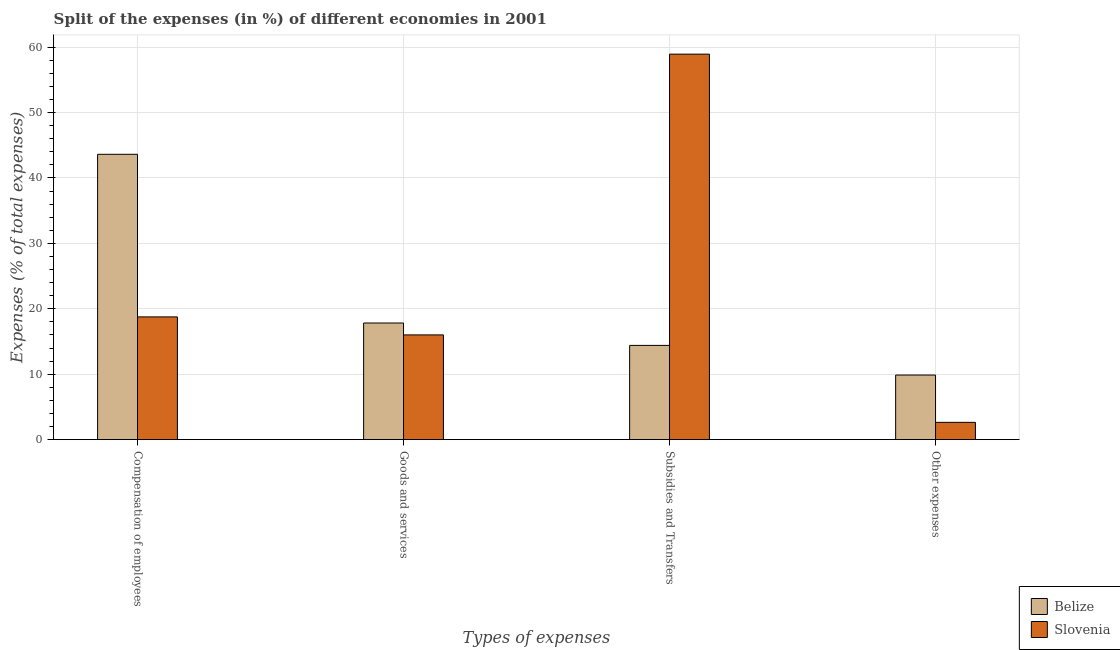How many different coloured bars are there?
Your response must be concise. 2. How many groups of bars are there?
Make the answer very short. 4. Are the number of bars per tick equal to the number of legend labels?
Keep it short and to the point. Yes. Are the number of bars on each tick of the X-axis equal?
Provide a succinct answer. Yes. How many bars are there on the 3rd tick from the left?
Make the answer very short. 2. What is the label of the 2nd group of bars from the left?
Give a very brief answer. Goods and services. What is the percentage of amount spent on compensation of employees in Belize?
Keep it short and to the point. 43.61. Across all countries, what is the maximum percentage of amount spent on other expenses?
Provide a short and direct response. 9.87. Across all countries, what is the minimum percentage of amount spent on compensation of employees?
Give a very brief answer. 18.76. In which country was the percentage of amount spent on goods and services maximum?
Provide a short and direct response. Belize. In which country was the percentage of amount spent on other expenses minimum?
Keep it short and to the point. Slovenia. What is the total percentage of amount spent on other expenses in the graph?
Give a very brief answer. 12.51. What is the difference between the percentage of amount spent on compensation of employees in Belize and that in Slovenia?
Give a very brief answer. 24.85. What is the difference between the percentage of amount spent on compensation of employees in Belize and the percentage of amount spent on other expenses in Slovenia?
Provide a short and direct response. 40.97. What is the average percentage of amount spent on goods and services per country?
Offer a very short reply. 16.91. What is the difference between the percentage of amount spent on subsidies and percentage of amount spent on goods and services in Slovenia?
Your answer should be compact. 42.91. In how many countries, is the percentage of amount spent on goods and services greater than 58 %?
Provide a succinct answer. 0. What is the ratio of the percentage of amount spent on subsidies in Belize to that in Slovenia?
Keep it short and to the point. 0.24. What is the difference between the highest and the second highest percentage of amount spent on compensation of employees?
Give a very brief answer. 24.85. What is the difference between the highest and the lowest percentage of amount spent on goods and services?
Your answer should be compact. 1.82. In how many countries, is the percentage of amount spent on goods and services greater than the average percentage of amount spent on goods and services taken over all countries?
Your response must be concise. 1. What does the 1st bar from the left in Compensation of employees represents?
Offer a terse response. Belize. What does the 2nd bar from the right in Compensation of employees represents?
Provide a short and direct response. Belize. Is it the case that in every country, the sum of the percentage of amount spent on compensation of employees and percentage of amount spent on goods and services is greater than the percentage of amount spent on subsidies?
Give a very brief answer. No. How many bars are there?
Give a very brief answer. 8. What is the difference between two consecutive major ticks on the Y-axis?
Provide a short and direct response. 10. Does the graph contain any zero values?
Provide a short and direct response. No. Does the graph contain grids?
Provide a succinct answer. Yes. How many legend labels are there?
Ensure brevity in your answer.  2. How are the legend labels stacked?
Your answer should be very brief. Vertical. What is the title of the graph?
Provide a succinct answer. Split of the expenses (in %) of different economies in 2001. What is the label or title of the X-axis?
Provide a short and direct response. Types of expenses. What is the label or title of the Y-axis?
Ensure brevity in your answer.  Expenses (% of total expenses). What is the Expenses (% of total expenses) of Belize in Compensation of employees?
Your answer should be very brief. 43.61. What is the Expenses (% of total expenses) of Slovenia in Compensation of employees?
Ensure brevity in your answer.  18.76. What is the Expenses (% of total expenses) in Belize in Goods and services?
Ensure brevity in your answer.  17.82. What is the Expenses (% of total expenses) of Slovenia in Goods and services?
Your answer should be compact. 16.01. What is the Expenses (% of total expenses) in Belize in Subsidies and Transfers?
Give a very brief answer. 14.4. What is the Expenses (% of total expenses) in Slovenia in Subsidies and Transfers?
Your response must be concise. 58.92. What is the Expenses (% of total expenses) in Belize in Other expenses?
Offer a very short reply. 9.87. What is the Expenses (% of total expenses) in Slovenia in Other expenses?
Give a very brief answer. 2.64. Across all Types of expenses, what is the maximum Expenses (% of total expenses) of Belize?
Make the answer very short. 43.61. Across all Types of expenses, what is the maximum Expenses (% of total expenses) in Slovenia?
Your response must be concise. 58.92. Across all Types of expenses, what is the minimum Expenses (% of total expenses) of Belize?
Make the answer very short. 9.87. Across all Types of expenses, what is the minimum Expenses (% of total expenses) in Slovenia?
Keep it short and to the point. 2.64. What is the total Expenses (% of total expenses) of Belize in the graph?
Offer a very short reply. 85.7. What is the total Expenses (% of total expenses) of Slovenia in the graph?
Provide a succinct answer. 96.32. What is the difference between the Expenses (% of total expenses) of Belize in Compensation of employees and that in Goods and services?
Ensure brevity in your answer.  25.79. What is the difference between the Expenses (% of total expenses) of Slovenia in Compensation of employees and that in Goods and services?
Provide a succinct answer. 2.75. What is the difference between the Expenses (% of total expenses) in Belize in Compensation of employees and that in Subsidies and Transfers?
Provide a succinct answer. 29.21. What is the difference between the Expenses (% of total expenses) of Slovenia in Compensation of employees and that in Subsidies and Transfers?
Ensure brevity in your answer.  -40.16. What is the difference between the Expenses (% of total expenses) of Belize in Compensation of employees and that in Other expenses?
Your answer should be compact. 33.74. What is the difference between the Expenses (% of total expenses) in Slovenia in Compensation of employees and that in Other expenses?
Ensure brevity in your answer.  16.12. What is the difference between the Expenses (% of total expenses) in Belize in Goods and services and that in Subsidies and Transfers?
Your answer should be compact. 3.42. What is the difference between the Expenses (% of total expenses) of Slovenia in Goods and services and that in Subsidies and Transfers?
Keep it short and to the point. -42.91. What is the difference between the Expenses (% of total expenses) in Belize in Goods and services and that in Other expenses?
Keep it short and to the point. 7.95. What is the difference between the Expenses (% of total expenses) in Slovenia in Goods and services and that in Other expenses?
Offer a very short reply. 13.37. What is the difference between the Expenses (% of total expenses) of Belize in Subsidies and Transfers and that in Other expenses?
Ensure brevity in your answer.  4.53. What is the difference between the Expenses (% of total expenses) of Slovenia in Subsidies and Transfers and that in Other expenses?
Provide a short and direct response. 56.28. What is the difference between the Expenses (% of total expenses) in Belize in Compensation of employees and the Expenses (% of total expenses) in Slovenia in Goods and services?
Your answer should be very brief. 27.6. What is the difference between the Expenses (% of total expenses) in Belize in Compensation of employees and the Expenses (% of total expenses) in Slovenia in Subsidies and Transfers?
Your response must be concise. -15.31. What is the difference between the Expenses (% of total expenses) of Belize in Compensation of employees and the Expenses (% of total expenses) of Slovenia in Other expenses?
Offer a very short reply. 40.97. What is the difference between the Expenses (% of total expenses) of Belize in Goods and services and the Expenses (% of total expenses) of Slovenia in Subsidies and Transfers?
Offer a terse response. -41.1. What is the difference between the Expenses (% of total expenses) of Belize in Goods and services and the Expenses (% of total expenses) of Slovenia in Other expenses?
Give a very brief answer. 15.18. What is the difference between the Expenses (% of total expenses) of Belize in Subsidies and Transfers and the Expenses (% of total expenses) of Slovenia in Other expenses?
Make the answer very short. 11.76. What is the average Expenses (% of total expenses) of Belize per Types of expenses?
Your answer should be compact. 21.43. What is the average Expenses (% of total expenses) of Slovenia per Types of expenses?
Your answer should be compact. 24.08. What is the difference between the Expenses (% of total expenses) in Belize and Expenses (% of total expenses) in Slovenia in Compensation of employees?
Your answer should be compact. 24.85. What is the difference between the Expenses (% of total expenses) of Belize and Expenses (% of total expenses) of Slovenia in Goods and services?
Make the answer very short. 1.82. What is the difference between the Expenses (% of total expenses) of Belize and Expenses (% of total expenses) of Slovenia in Subsidies and Transfers?
Ensure brevity in your answer.  -44.52. What is the difference between the Expenses (% of total expenses) of Belize and Expenses (% of total expenses) of Slovenia in Other expenses?
Keep it short and to the point. 7.23. What is the ratio of the Expenses (% of total expenses) of Belize in Compensation of employees to that in Goods and services?
Provide a short and direct response. 2.45. What is the ratio of the Expenses (% of total expenses) of Slovenia in Compensation of employees to that in Goods and services?
Your answer should be very brief. 1.17. What is the ratio of the Expenses (% of total expenses) in Belize in Compensation of employees to that in Subsidies and Transfers?
Offer a very short reply. 3.03. What is the ratio of the Expenses (% of total expenses) of Slovenia in Compensation of employees to that in Subsidies and Transfers?
Offer a very short reply. 0.32. What is the ratio of the Expenses (% of total expenses) in Belize in Compensation of employees to that in Other expenses?
Offer a very short reply. 4.42. What is the ratio of the Expenses (% of total expenses) of Slovenia in Compensation of employees to that in Other expenses?
Your answer should be compact. 7.11. What is the ratio of the Expenses (% of total expenses) of Belize in Goods and services to that in Subsidies and Transfers?
Ensure brevity in your answer.  1.24. What is the ratio of the Expenses (% of total expenses) of Slovenia in Goods and services to that in Subsidies and Transfers?
Offer a very short reply. 0.27. What is the ratio of the Expenses (% of total expenses) of Belize in Goods and services to that in Other expenses?
Keep it short and to the point. 1.81. What is the ratio of the Expenses (% of total expenses) in Slovenia in Goods and services to that in Other expenses?
Your answer should be compact. 6.07. What is the ratio of the Expenses (% of total expenses) of Belize in Subsidies and Transfers to that in Other expenses?
Your answer should be compact. 1.46. What is the ratio of the Expenses (% of total expenses) of Slovenia in Subsidies and Transfers to that in Other expenses?
Offer a very short reply. 22.33. What is the difference between the highest and the second highest Expenses (% of total expenses) of Belize?
Your answer should be compact. 25.79. What is the difference between the highest and the second highest Expenses (% of total expenses) of Slovenia?
Make the answer very short. 40.16. What is the difference between the highest and the lowest Expenses (% of total expenses) of Belize?
Make the answer very short. 33.74. What is the difference between the highest and the lowest Expenses (% of total expenses) in Slovenia?
Offer a terse response. 56.28. 